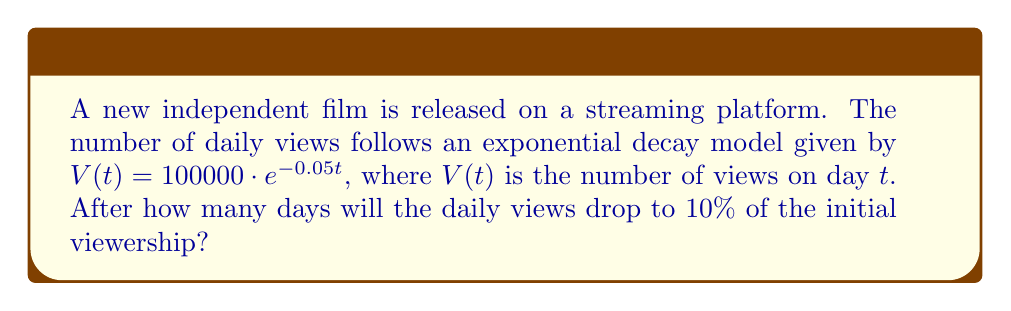Help me with this question. To solve this problem, we need to use logarithms. Let's approach this step-by-step:

1) We want to find $t$ when $V(t)$ is 10% of the initial viewership.
   Initial viewership: $V(0) = 100000$
   10% of initial: $0.1 \cdot 100000 = 10000$

2) Set up the equation:
   $10000 = 100000 \cdot e^{-0.05t}$

3) Divide both sides by 100000:
   $0.1 = e^{-0.05t}$

4) Take the natural logarithm of both sides:
   $\ln(0.1) = \ln(e^{-0.05t})$

5) Simplify the right side using logarithm properties:
   $\ln(0.1) = -0.05t$

6) Solve for $t$:
   $t = \frac{\ln(0.1)}{-0.05}$

7) Calculate:
   $t = \frac{\ln(0.1)}{-0.05} \approx 46.05$

8) Since we're dealing with days, we round up to the nearest whole number.

Therefore, it will take 47 days for the daily views to drop to 10% of the initial viewership.
Answer: 47 days 